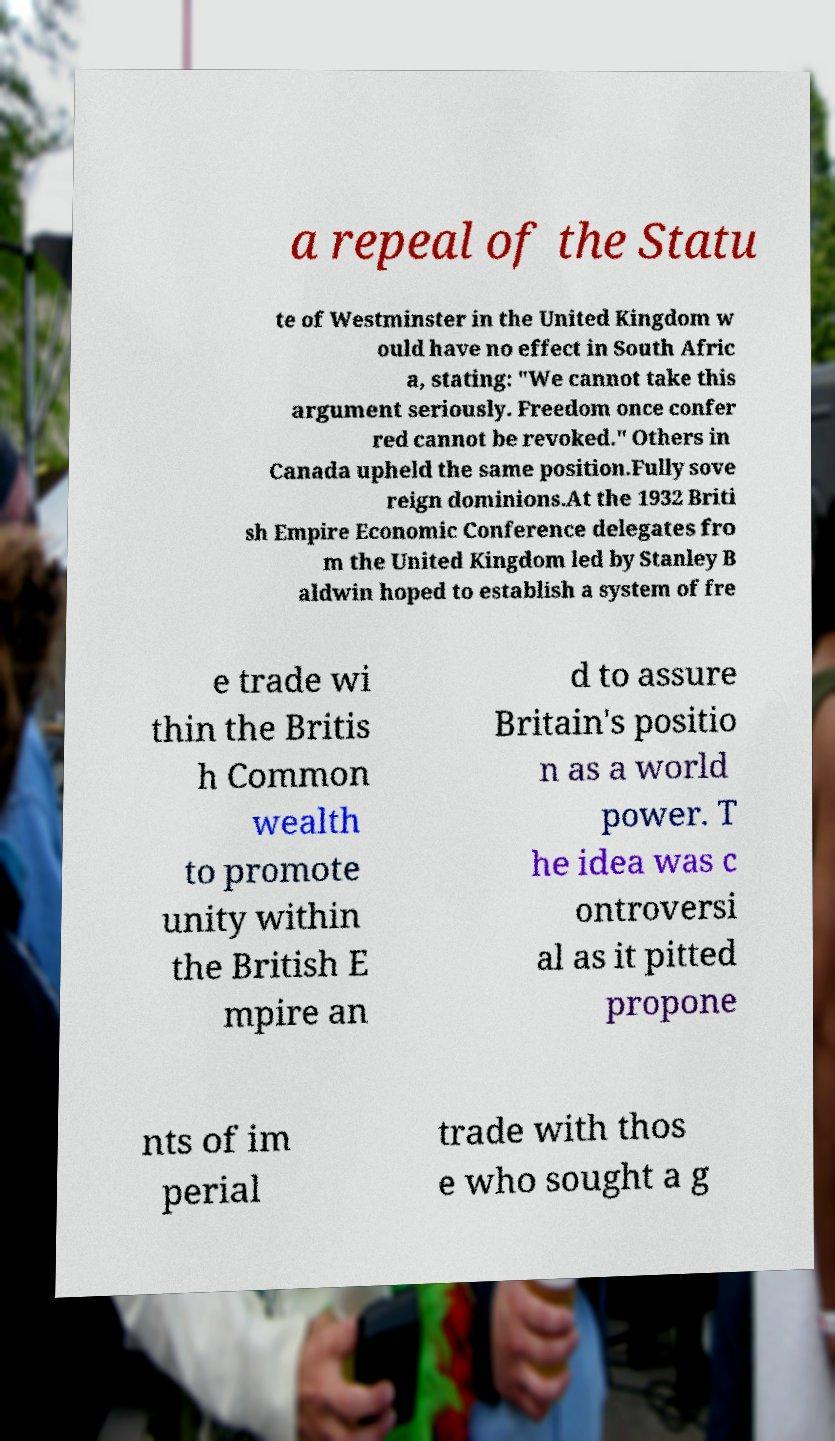Could you extract and type out the text from this image? a repeal of the Statu te of Westminster in the United Kingdom w ould have no effect in South Afric a, stating: "We cannot take this argument seriously. Freedom once confer red cannot be revoked." Others in Canada upheld the same position.Fully sove reign dominions.At the 1932 Briti sh Empire Economic Conference delegates fro m the United Kingdom led by Stanley B aldwin hoped to establish a system of fre e trade wi thin the Britis h Common wealth to promote unity within the British E mpire an d to assure Britain's positio n as a world power. T he idea was c ontroversi al as it pitted propone nts of im perial trade with thos e who sought a g 